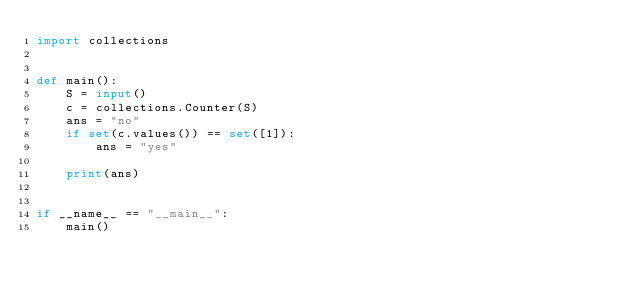<code> <loc_0><loc_0><loc_500><loc_500><_Python_>import collections


def main():
    S = input()
    c = collections.Counter(S)
    ans = "no"
    if set(c.values()) == set([1]):
        ans = "yes"

    print(ans)


if __name__ == "__main__":
    main()
</code> 